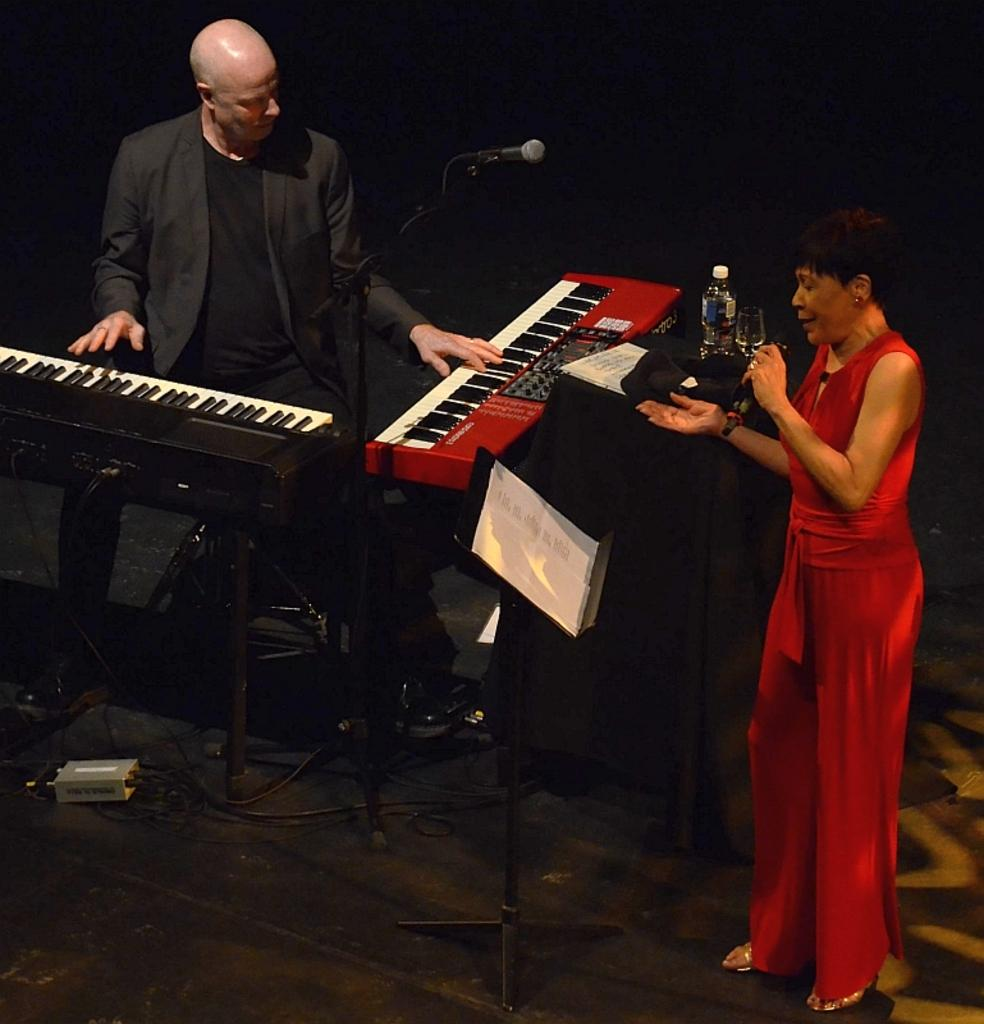What is the woman in the image doing? The woman is singing. How is the woman amplifying her voice in the image? The woman is using a microphone. What is the person in the image doing? The person is playing a piano. How is the piano positioned in relation to the person? The piano is in front of the person. What type of hair product is visible on the woman's hair in the image? There is no hair product visible on the woman's hair in the image. What month is it in the image? The month cannot be determined from the image. How many flies can be seen flying around the microphone in the image? There are no flies visible in the image. 